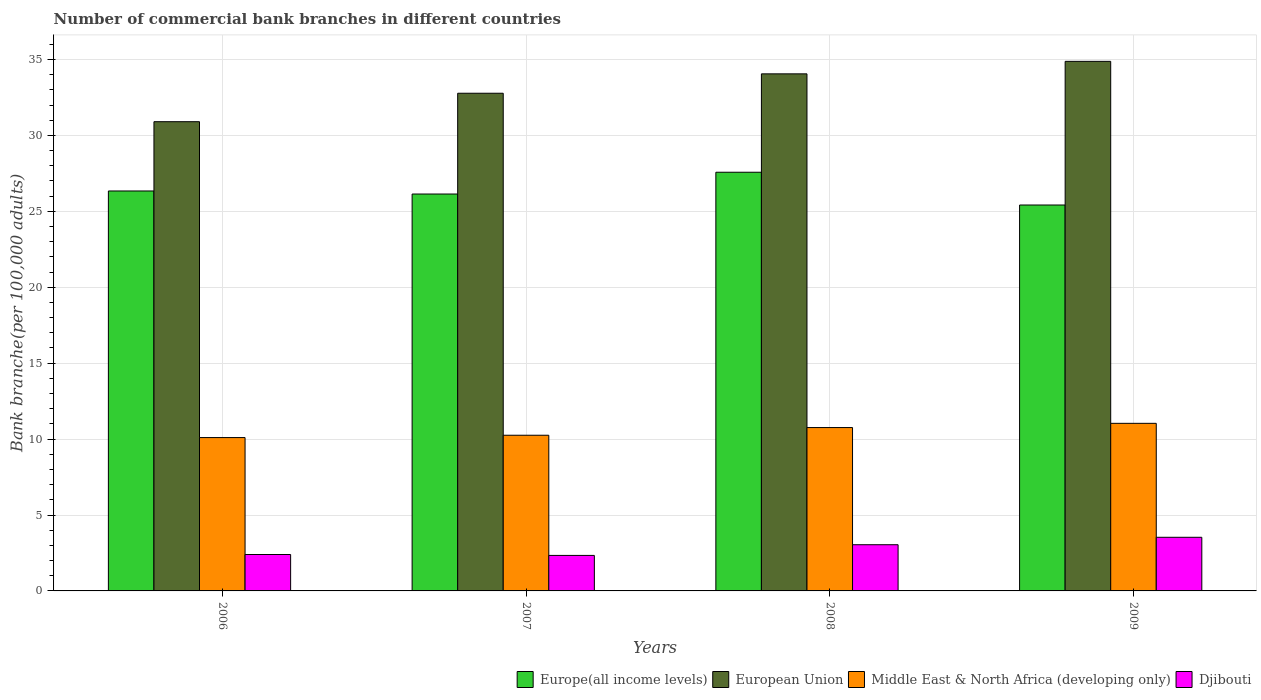Are the number of bars on each tick of the X-axis equal?
Ensure brevity in your answer.  Yes. What is the label of the 1st group of bars from the left?
Offer a very short reply. 2006. In how many cases, is the number of bars for a given year not equal to the number of legend labels?
Your answer should be compact. 0. What is the number of commercial bank branches in Middle East & North Africa (developing only) in 2006?
Your answer should be compact. 10.1. Across all years, what is the maximum number of commercial bank branches in Djibouti?
Your response must be concise. 3.53. Across all years, what is the minimum number of commercial bank branches in Djibouti?
Ensure brevity in your answer.  2.34. In which year was the number of commercial bank branches in Djibouti minimum?
Ensure brevity in your answer.  2007. What is the total number of commercial bank branches in Middle East & North Africa (developing only) in the graph?
Your answer should be very brief. 42.15. What is the difference between the number of commercial bank branches in Europe(all income levels) in 2006 and that in 2007?
Provide a short and direct response. 0.2. What is the difference between the number of commercial bank branches in Djibouti in 2007 and the number of commercial bank branches in Europe(all income levels) in 2008?
Keep it short and to the point. -25.24. What is the average number of commercial bank branches in European Union per year?
Make the answer very short. 33.15. In the year 2006, what is the difference between the number of commercial bank branches in Djibouti and number of commercial bank branches in Middle East & North Africa (developing only)?
Provide a succinct answer. -7.7. In how many years, is the number of commercial bank branches in European Union greater than 3?
Your answer should be compact. 4. What is the ratio of the number of commercial bank branches in European Union in 2006 to that in 2007?
Ensure brevity in your answer.  0.94. What is the difference between the highest and the second highest number of commercial bank branches in European Union?
Make the answer very short. 0.82. What is the difference between the highest and the lowest number of commercial bank branches in European Union?
Provide a succinct answer. 3.97. Is the sum of the number of commercial bank branches in Djibouti in 2007 and 2009 greater than the maximum number of commercial bank branches in European Union across all years?
Make the answer very short. No. What does the 1st bar from the left in 2006 represents?
Keep it short and to the point. Europe(all income levels). What does the 1st bar from the right in 2007 represents?
Make the answer very short. Djibouti. How many bars are there?
Offer a terse response. 16. How many years are there in the graph?
Provide a succinct answer. 4. Are the values on the major ticks of Y-axis written in scientific E-notation?
Your response must be concise. No. Where does the legend appear in the graph?
Keep it short and to the point. Bottom right. How are the legend labels stacked?
Ensure brevity in your answer.  Horizontal. What is the title of the graph?
Give a very brief answer. Number of commercial bank branches in different countries. What is the label or title of the X-axis?
Offer a very short reply. Years. What is the label or title of the Y-axis?
Provide a succinct answer. Bank branche(per 100,0 adults). What is the Bank branche(per 100,000 adults) in Europe(all income levels) in 2006?
Ensure brevity in your answer.  26.34. What is the Bank branche(per 100,000 adults) in European Union in 2006?
Give a very brief answer. 30.9. What is the Bank branche(per 100,000 adults) of Middle East & North Africa (developing only) in 2006?
Your response must be concise. 10.1. What is the Bank branche(per 100,000 adults) in Djibouti in 2006?
Provide a succinct answer. 2.4. What is the Bank branche(per 100,000 adults) of Europe(all income levels) in 2007?
Ensure brevity in your answer.  26.14. What is the Bank branche(per 100,000 adults) in European Union in 2007?
Your response must be concise. 32.78. What is the Bank branche(per 100,000 adults) in Middle East & North Africa (developing only) in 2007?
Provide a succinct answer. 10.25. What is the Bank branche(per 100,000 adults) of Djibouti in 2007?
Your answer should be compact. 2.34. What is the Bank branche(per 100,000 adults) in Europe(all income levels) in 2008?
Offer a very short reply. 27.57. What is the Bank branche(per 100,000 adults) in European Union in 2008?
Ensure brevity in your answer.  34.05. What is the Bank branche(per 100,000 adults) in Middle East & North Africa (developing only) in 2008?
Give a very brief answer. 10.76. What is the Bank branche(per 100,000 adults) of Djibouti in 2008?
Offer a very short reply. 3.04. What is the Bank branche(per 100,000 adults) of Europe(all income levels) in 2009?
Your answer should be compact. 25.42. What is the Bank branche(per 100,000 adults) of European Union in 2009?
Give a very brief answer. 34.88. What is the Bank branche(per 100,000 adults) in Middle East & North Africa (developing only) in 2009?
Offer a very short reply. 11.04. What is the Bank branche(per 100,000 adults) of Djibouti in 2009?
Provide a succinct answer. 3.53. Across all years, what is the maximum Bank branche(per 100,000 adults) in Europe(all income levels)?
Offer a terse response. 27.57. Across all years, what is the maximum Bank branche(per 100,000 adults) of European Union?
Your answer should be compact. 34.88. Across all years, what is the maximum Bank branche(per 100,000 adults) in Middle East & North Africa (developing only)?
Offer a very short reply. 11.04. Across all years, what is the maximum Bank branche(per 100,000 adults) of Djibouti?
Your answer should be compact. 3.53. Across all years, what is the minimum Bank branche(per 100,000 adults) of Europe(all income levels)?
Your answer should be compact. 25.42. Across all years, what is the minimum Bank branche(per 100,000 adults) of European Union?
Ensure brevity in your answer.  30.9. Across all years, what is the minimum Bank branche(per 100,000 adults) in Middle East & North Africa (developing only)?
Provide a succinct answer. 10.1. Across all years, what is the minimum Bank branche(per 100,000 adults) in Djibouti?
Ensure brevity in your answer.  2.34. What is the total Bank branche(per 100,000 adults) of Europe(all income levels) in the graph?
Provide a short and direct response. 105.47. What is the total Bank branche(per 100,000 adults) in European Union in the graph?
Provide a succinct answer. 132.61. What is the total Bank branche(per 100,000 adults) in Middle East & North Africa (developing only) in the graph?
Your answer should be compact. 42.15. What is the total Bank branche(per 100,000 adults) of Djibouti in the graph?
Keep it short and to the point. 11.31. What is the difference between the Bank branche(per 100,000 adults) of Europe(all income levels) in 2006 and that in 2007?
Your answer should be compact. 0.2. What is the difference between the Bank branche(per 100,000 adults) in European Union in 2006 and that in 2007?
Your response must be concise. -1.87. What is the difference between the Bank branche(per 100,000 adults) in Middle East & North Africa (developing only) in 2006 and that in 2007?
Ensure brevity in your answer.  -0.15. What is the difference between the Bank branche(per 100,000 adults) of Djibouti in 2006 and that in 2007?
Provide a succinct answer. 0.06. What is the difference between the Bank branche(per 100,000 adults) of Europe(all income levels) in 2006 and that in 2008?
Your answer should be compact. -1.23. What is the difference between the Bank branche(per 100,000 adults) of European Union in 2006 and that in 2008?
Provide a succinct answer. -3.15. What is the difference between the Bank branche(per 100,000 adults) in Middle East & North Africa (developing only) in 2006 and that in 2008?
Your response must be concise. -0.66. What is the difference between the Bank branche(per 100,000 adults) in Djibouti in 2006 and that in 2008?
Provide a short and direct response. -0.64. What is the difference between the Bank branche(per 100,000 adults) in Europe(all income levels) in 2006 and that in 2009?
Offer a very short reply. 0.92. What is the difference between the Bank branche(per 100,000 adults) in European Union in 2006 and that in 2009?
Offer a very short reply. -3.97. What is the difference between the Bank branche(per 100,000 adults) of Middle East & North Africa (developing only) in 2006 and that in 2009?
Your response must be concise. -0.94. What is the difference between the Bank branche(per 100,000 adults) in Djibouti in 2006 and that in 2009?
Ensure brevity in your answer.  -1.13. What is the difference between the Bank branche(per 100,000 adults) of Europe(all income levels) in 2007 and that in 2008?
Provide a short and direct response. -1.43. What is the difference between the Bank branche(per 100,000 adults) of European Union in 2007 and that in 2008?
Offer a very short reply. -1.28. What is the difference between the Bank branche(per 100,000 adults) in Middle East & North Africa (developing only) in 2007 and that in 2008?
Keep it short and to the point. -0.51. What is the difference between the Bank branche(per 100,000 adults) in Djibouti in 2007 and that in 2008?
Offer a very short reply. -0.7. What is the difference between the Bank branche(per 100,000 adults) in Europe(all income levels) in 2007 and that in 2009?
Your answer should be compact. 0.72. What is the difference between the Bank branche(per 100,000 adults) in European Union in 2007 and that in 2009?
Give a very brief answer. -2.1. What is the difference between the Bank branche(per 100,000 adults) of Middle East & North Africa (developing only) in 2007 and that in 2009?
Offer a terse response. -0.78. What is the difference between the Bank branche(per 100,000 adults) in Djibouti in 2007 and that in 2009?
Provide a short and direct response. -1.19. What is the difference between the Bank branche(per 100,000 adults) in Europe(all income levels) in 2008 and that in 2009?
Offer a terse response. 2.16. What is the difference between the Bank branche(per 100,000 adults) of European Union in 2008 and that in 2009?
Provide a short and direct response. -0.82. What is the difference between the Bank branche(per 100,000 adults) of Middle East & North Africa (developing only) in 2008 and that in 2009?
Your answer should be very brief. -0.28. What is the difference between the Bank branche(per 100,000 adults) in Djibouti in 2008 and that in 2009?
Your answer should be very brief. -0.49. What is the difference between the Bank branche(per 100,000 adults) of Europe(all income levels) in 2006 and the Bank branche(per 100,000 adults) of European Union in 2007?
Provide a short and direct response. -6.44. What is the difference between the Bank branche(per 100,000 adults) in Europe(all income levels) in 2006 and the Bank branche(per 100,000 adults) in Middle East & North Africa (developing only) in 2007?
Your answer should be compact. 16.09. What is the difference between the Bank branche(per 100,000 adults) in Europe(all income levels) in 2006 and the Bank branche(per 100,000 adults) in Djibouti in 2007?
Give a very brief answer. 24. What is the difference between the Bank branche(per 100,000 adults) of European Union in 2006 and the Bank branche(per 100,000 adults) of Middle East & North Africa (developing only) in 2007?
Keep it short and to the point. 20.65. What is the difference between the Bank branche(per 100,000 adults) in European Union in 2006 and the Bank branche(per 100,000 adults) in Djibouti in 2007?
Your response must be concise. 28.57. What is the difference between the Bank branche(per 100,000 adults) in Middle East & North Africa (developing only) in 2006 and the Bank branche(per 100,000 adults) in Djibouti in 2007?
Provide a short and direct response. 7.76. What is the difference between the Bank branche(per 100,000 adults) in Europe(all income levels) in 2006 and the Bank branche(per 100,000 adults) in European Union in 2008?
Offer a very short reply. -7.71. What is the difference between the Bank branche(per 100,000 adults) in Europe(all income levels) in 2006 and the Bank branche(per 100,000 adults) in Middle East & North Africa (developing only) in 2008?
Your answer should be very brief. 15.58. What is the difference between the Bank branche(per 100,000 adults) in Europe(all income levels) in 2006 and the Bank branche(per 100,000 adults) in Djibouti in 2008?
Ensure brevity in your answer.  23.3. What is the difference between the Bank branche(per 100,000 adults) of European Union in 2006 and the Bank branche(per 100,000 adults) of Middle East & North Africa (developing only) in 2008?
Ensure brevity in your answer.  20.14. What is the difference between the Bank branche(per 100,000 adults) in European Union in 2006 and the Bank branche(per 100,000 adults) in Djibouti in 2008?
Your answer should be very brief. 27.86. What is the difference between the Bank branche(per 100,000 adults) of Middle East & North Africa (developing only) in 2006 and the Bank branche(per 100,000 adults) of Djibouti in 2008?
Provide a short and direct response. 7.06. What is the difference between the Bank branche(per 100,000 adults) in Europe(all income levels) in 2006 and the Bank branche(per 100,000 adults) in European Union in 2009?
Make the answer very short. -8.54. What is the difference between the Bank branche(per 100,000 adults) in Europe(all income levels) in 2006 and the Bank branche(per 100,000 adults) in Middle East & North Africa (developing only) in 2009?
Your response must be concise. 15.3. What is the difference between the Bank branche(per 100,000 adults) in Europe(all income levels) in 2006 and the Bank branche(per 100,000 adults) in Djibouti in 2009?
Your response must be concise. 22.81. What is the difference between the Bank branche(per 100,000 adults) in European Union in 2006 and the Bank branche(per 100,000 adults) in Middle East & North Africa (developing only) in 2009?
Make the answer very short. 19.87. What is the difference between the Bank branche(per 100,000 adults) of European Union in 2006 and the Bank branche(per 100,000 adults) of Djibouti in 2009?
Your response must be concise. 27.37. What is the difference between the Bank branche(per 100,000 adults) in Middle East & North Africa (developing only) in 2006 and the Bank branche(per 100,000 adults) in Djibouti in 2009?
Provide a short and direct response. 6.57. What is the difference between the Bank branche(per 100,000 adults) in Europe(all income levels) in 2007 and the Bank branche(per 100,000 adults) in European Union in 2008?
Ensure brevity in your answer.  -7.91. What is the difference between the Bank branche(per 100,000 adults) of Europe(all income levels) in 2007 and the Bank branche(per 100,000 adults) of Middle East & North Africa (developing only) in 2008?
Offer a very short reply. 15.38. What is the difference between the Bank branche(per 100,000 adults) of Europe(all income levels) in 2007 and the Bank branche(per 100,000 adults) of Djibouti in 2008?
Provide a succinct answer. 23.1. What is the difference between the Bank branche(per 100,000 adults) of European Union in 2007 and the Bank branche(per 100,000 adults) of Middle East & North Africa (developing only) in 2008?
Provide a succinct answer. 22.02. What is the difference between the Bank branche(per 100,000 adults) of European Union in 2007 and the Bank branche(per 100,000 adults) of Djibouti in 2008?
Your response must be concise. 29.74. What is the difference between the Bank branche(per 100,000 adults) in Middle East & North Africa (developing only) in 2007 and the Bank branche(per 100,000 adults) in Djibouti in 2008?
Provide a succinct answer. 7.21. What is the difference between the Bank branche(per 100,000 adults) in Europe(all income levels) in 2007 and the Bank branche(per 100,000 adults) in European Union in 2009?
Provide a succinct answer. -8.74. What is the difference between the Bank branche(per 100,000 adults) in Europe(all income levels) in 2007 and the Bank branche(per 100,000 adults) in Middle East & North Africa (developing only) in 2009?
Your response must be concise. 15.1. What is the difference between the Bank branche(per 100,000 adults) in Europe(all income levels) in 2007 and the Bank branche(per 100,000 adults) in Djibouti in 2009?
Provide a short and direct response. 22.61. What is the difference between the Bank branche(per 100,000 adults) in European Union in 2007 and the Bank branche(per 100,000 adults) in Middle East & North Africa (developing only) in 2009?
Offer a very short reply. 21.74. What is the difference between the Bank branche(per 100,000 adults) in European Union in 2007 and the Bank branche(per 100,000 adults) in Djibouti in 2009?
Provide a succinct answer. 29.25. What is the difference between the Bank branche(per 100,000 adults) in Middle East & North Africa (developing only) in 2007 and the Bank branche(per 100,000 adults) in Djibouti in 2009?
Your answer should be very brief. 6.72. What is the difference between the Bank branche(per 100,000 adults) in Europe(all income levels) in 2008 and the Bank branche(per 100,000 adults) in European Union in 2009?
Provide a short and direct response. -7.3. What is the difference between the Bank branche(per 100,000 adults) in Europe(all income levels) in 2008 and the Bank branche(per 100,000 adults) in Middle East & North Africa (developing only) in 2009?
Keep it short and to the point. 16.54. What is the difference between the Bank branche(per 100,000 adults) of Europe(all income levels) in 2008 and the Bank branche(per 100,000 adults) of Djibouti in 2009?
Ensure brevity in your answer.  24.04. What is the difference between the Bank branche(per 100,000 adults) of European Union in 2008 and the Bank branche(per 100,000 adults) of Middle East & North Africa (developing only) in 2009?
Keep it short and to the point. 23.02. What is the difference between the Bank branche(per 100,000 adults) of European Union in 2008 and the Bank branche(per 100,000 adults) of Djibouti in 2009?
Provide a short and direct response. 30.52. What is the difference between the Bank branche(per 100,000 adults) of Middle East & North Africa (developing only) in 2008 and the Bank branche(per 100,000 adults) of Djibouti in 2009?
Offer a very short reply. 7.23. What is the average Bank branche(per 100,000 adults) in Europe(all income levels) per year?
Ensure brevity in your answer.  26.37. What is the average Bank branche(per 100,000 adults) of European Union per year?
Provide a succinct answer. 33.15. What is the average Bank branche(per 100,000 adults) of Middle East & North Africa (developing only) per year?
Your response must be concise. 10.54. What is the average Bank branche(per 100,000 adults) in Djibouti per year?
Provide a short and direct response. 2.83. In the year 2006, what is the difference between the Bank branche(per 100,000 adults) of Europe(all income levels) and Bank branche(per 100,000 adults) of European Union?
Ensure brevity in your answer.  -4.56. In the year 2006, what is the difference between the Bank branche(per 100,000 adults) in Europe(all income levels) and Bank branche(per 100,000 adults) in Middle East & North Africa (developing only)?
Your answer should be very brief. 16.24. In the year 2006, what is the difference between the Bank branche(per 100,000 adults) in Europe(all income levels) and Bank branche(per 100,000 adults) in Djibouti?
Provide a succinct answer. 23.94. In the year 2006, what is the difference between the Bank branche(per 100,000 adults) of European Union and Bank branche(per 100,000 adults) of Middle East & North Africa (developing only)?
Ensure brevity in your answer.  20.8. In the year 2006, what is the difference between the Bank branche(per 100,000 adults) in European Union and Bank branche(per 100,000 adults) in Djibouti?
Keep it short and to the point. 28.51. In the year 2006, what is the difference between the Bank branche(per 100,000 adults) of Middle East & North Africa (developing only) and Bank branche(per 100,000 adults) of Djibouti?
Ensure brevity in your answer.  7.7. In the year 2007, what is the difference between the Bank branche(per 100,000 adults) of Europe(all income levels) and Bank branche(per 100,000 adults) of European Union?
Provide a short and direct response. -6.64. In the year 2007, what is the difference between the Bank branche(per 100,000 adults) of Europe(all income levels) and Bank branche(per 100,000 adults) of Middle East & North Africa (developing only)?
Offer a terse response. 15.89. In the year 2007, what is the difference between the Bank branche(per 100,000 adults) of Europe(all income levels) and Bank branche(per 100,000 adults) of Djibouti?
Give a very brief answer. 23.8. In the year 2007, what is the difference between the Bank branche(per 100,000 adults) in European Union and Bank branche(per 100,000 adults) in Middle East & North Africa (developing only)?
Provide a succinct answer. 22.52. In the year 2007, what is the difference between the Bank branche(per 100,000 adults) of European Union and Bank branche(per 100,000 adults) of Djibouti?
Your answer should be very brief. 30.44. In the year 2007, what is the difference between the Bank branche(per 100,000 adults) of Middle East & North Africa (developing only) and Bank branche(per 100,000 adults) of Djibouti?
Make the answer very short. 7.92. In the year 2008, what is the difference between the Bank branche(per 100,000 adults) of Europe(all income levels) and Bank branche(per 100,000 adults) of European Union?
Provide a short and direct response. -6.48. In the year 2008, what is the difference between the Bank branche(per 100,000 adults) of Europe(all income levels) and Bank branche(per 100,000 adults) of Middle East & North Africa (developing only)?
Give a very brief answer. 16.82. In the year 2008, what is the difference between the Bank branche(per 100,000 adults) in Europe(all income levels) and Bank branche(per 100,000 adults) in Djibouti?
Ensure brevity in your answer.  24.53. In the year 2008, what is the difference between the Bank branche(per 100,000 adults) in European Union and Bank branche(per 100,000 adults) in Middle East & North Africa (developing only)?
Provide a succinct answer. 23.29. In the year 2008, what is the difference between the Bank branche(per 100,000 adults) in European Union and Bank branche(per 100,000 adults) in Djibouti?
Ensure brevity in your answer.  31.01. In the year 2008, what is the difference between the Bank branche(per 100,000 adults) of Middle East & North Africa (developing only) and Bank branche(per 100,000 adults) of Djibouti?
Offer a terse response. 7.72. In the year 2009, what is the difference between the Bank branche(per 100,000 adults) of Europe(all income levels) and Bank branche(per 100,000 adults) of European Union?
Your answer should be compact. -9.46. In the year 2009, what is the difference between the Bank branche(per 100,000 adults) of Europe(all income levels) and Bank branche(per 100,000 adults) of Middle East & North Africa (developing only)?
Your answer should be compact. 14.38. In the year 2009, what is the difference between the Bank branche(per 100,000 adults) of Europe(all income levels) and Bank branche(per 100,000 adults) of Djibouti?
Provide a short and direct response. 21.88. In the year 2009, what is the difference between the Bank branche(per 100,000 adults) of European Union and Bank branche(per 100,000 adults) of Middle East & North Africa (developing only)?
Offer a terse response. 23.84. In the year 2009, what is the difference between the Bank branche(per 100,000 adults) of European Union and Bank branche(per 100,000 adults) of Djibouti?
Provide a short and direct response. 31.35. In the year 2009, what is the difference between the Bank branche(per 100,000 adults) in Middle East & North Africa (developing only) and Bank branche(per 100,000 adults) in Djibouti?
Provide a succinct answer. 7.51. What is the ratio of the Bank branche(per 100,000 adults) in Europe(all income levels) in 2006 to that in 2007?
Your answer should be compact. 1.01. What is the ratio of the Bank branche(per 100,000 adults) in European Union in 2006 to that in 2007?
Offer a very short reply. 0.94. What is the ratio of the Bank branche(per 100,000 adults) in Middle East & North Africa (developing only) in 2006 to that in 2007?
Offer a very short reply. 0.98. What is the ratio of the Bank branche(per 100,000 adults) of Djibouti in 2006 to that in 2007?
Offer a very short reply. 1.03. What is the ratio of the Bank branche(per 100,000 adults) in Europe(all income levels) in 2006 to that in 2008?
Offer a very short reply. 0.96. What is the ratio of the Bank branche(per 100,000 adults) of European Union in 2006 to that in 2008?
Provide a succinct answer. 0.91. What is the ratio of the Bank branche(per 100,000 adults) in Middle East & North Africa (developing only) in 2006 to that in 2008?
Offer a terse response. 0.94. What is the ratio of the Bank branche(per 100,000 adults) of Djibouti in 2006 to that in 2008?
Provide a succinct answer. 0.79. What is the ratio of the Bank branche(per 100,000 adults) in Europe(all income levels) in 2006 to that in 2009?
Provide a short and direct response. 1.04. What is the ratio of the Bank branche(per 100,000 adults) of European Union in 2006 to that in 2009?
Offer a very short reply. 0.89. What is the ratio of the Bank branche(per 100,000 adults) in Middle East & North Africa (developing only) in 2006 to that in 2009?
Your answer should be very brief. 0.92. What is the ratio of the Bank branche(per 100,000 adults) of Djibouti in 2006 to that in 2009?
Your answer should be compact. 0.68. What is the ratio of the Bank branche(per 100,000 adults) in Europe(all income levels) in 2007 to that in 2008?
Ensure brevity in your answer.  0.95. What is the ratio of the Bank branche(per 100,000 adults) in European Union in 2007 to that in 2008?
Give a very brief answer. 0.96. What is the ratio of the Bank branche(per 100,000 adults) in Middle East & North Africa (developing only) in 2007 to that in 2008?
Provide a short and direct response. 0.95. What is the ratio of the Bank branche(per 100,000 adults) of Djibouti in 2007 to that in 2008?
Ensure brevity in your answer.  0.77. What is the ratio of the Bank branche(per 100,000 adults) of Europe(all income levels) in 2007 to that in 2009?
Provide a short and direct response. 1.03. What is the ratio of the Bank branche(per 100,000 adults) in European Union in 2007 to that in 2009?
Offer a very short reply. 0.94. What is the ratio of the Bank branche(per 100,000 adults) in Middle East & North Africa (developing only) in 2007 to that in 2009?
Your response must be concise. 0.93. What is the ratio of the Bank branche(per 100,000 adults) of Djibouti in 2007 to that in 2009?
Offer a terse response. 0.66. What is the ratio of the Bank branche(per 100,000 adults) of Europe(all income levels) in 2008 to that in 2009?
Keep it short and to the point. 1.08. What is the ratio of the Bank branche(per 100,000 adults) in European Union in 2008 to that in 2009?
Ensure brevity in your answer.  0.98. What is the ratio of the Bank branche(per 100,000 adults) of Middle East & North Africa (developing only) in 2008 to that in 2009?
Keep it short and to the point. 0.97. What is the ratio of the Bank branche(per 100,000 adults) in Djibouti in 2008 to that in 2009?
Offer a very short reply. 0.86. What is the difference between the highest and the second highest Bank branche(per 100,000 adults) in Europe(all income levels)?
Offer a terse response. 1.23. What is the difference between the highest and the second highest Bank branche(per 100,000 adults) of European Union?
Ensure brevity in your answer.  0.82. What is the difference between the highest and the second highest Bank branche(per 100,000 adults) of Middle East & North Africa (developing only)?
Provide a short and direct response. 0.28. What is the difference between the highest and the second highest Bank branche(per 100,000 adults) in Djibouti?
Offer a very short reply. 0.49. What is the difference between the highest and the lowest Bank branche(per 100,000 adults) in Europe(all income levels)?
Give a very brief answer. 2.16. What is the difference between the highest and the lowest Bank branche(per 100,000 adults) in European Union?
Your response must be concise. 3.97. What is the difference between the highest and the lowest Bank branche(per 100,000 adults) in Middle East & North Africa (developing only)?
Give a very brief answer. 0.94. What is the difference between the highest and the lowest Bank branche(per 100,000 adults) in Djibouti?
Provide a short and direct response. 1.19. 